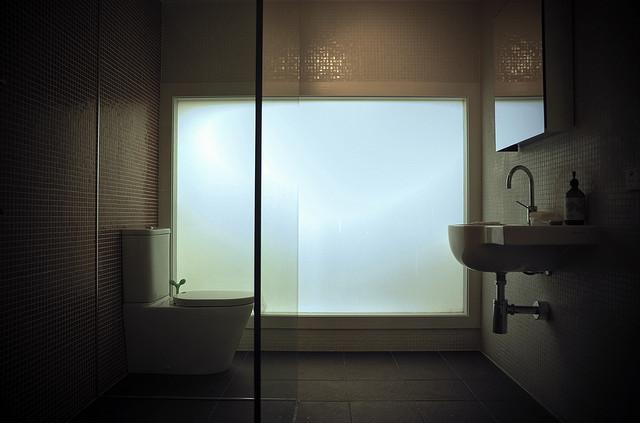Would people be able to see you pooping?
Give a very brief answer. Yes. What is the name of the sink fixture that the water comes out of?
Answer briefly. Faucet. Is the toilet behind a glass wall?
Concise answer only. Yes. 